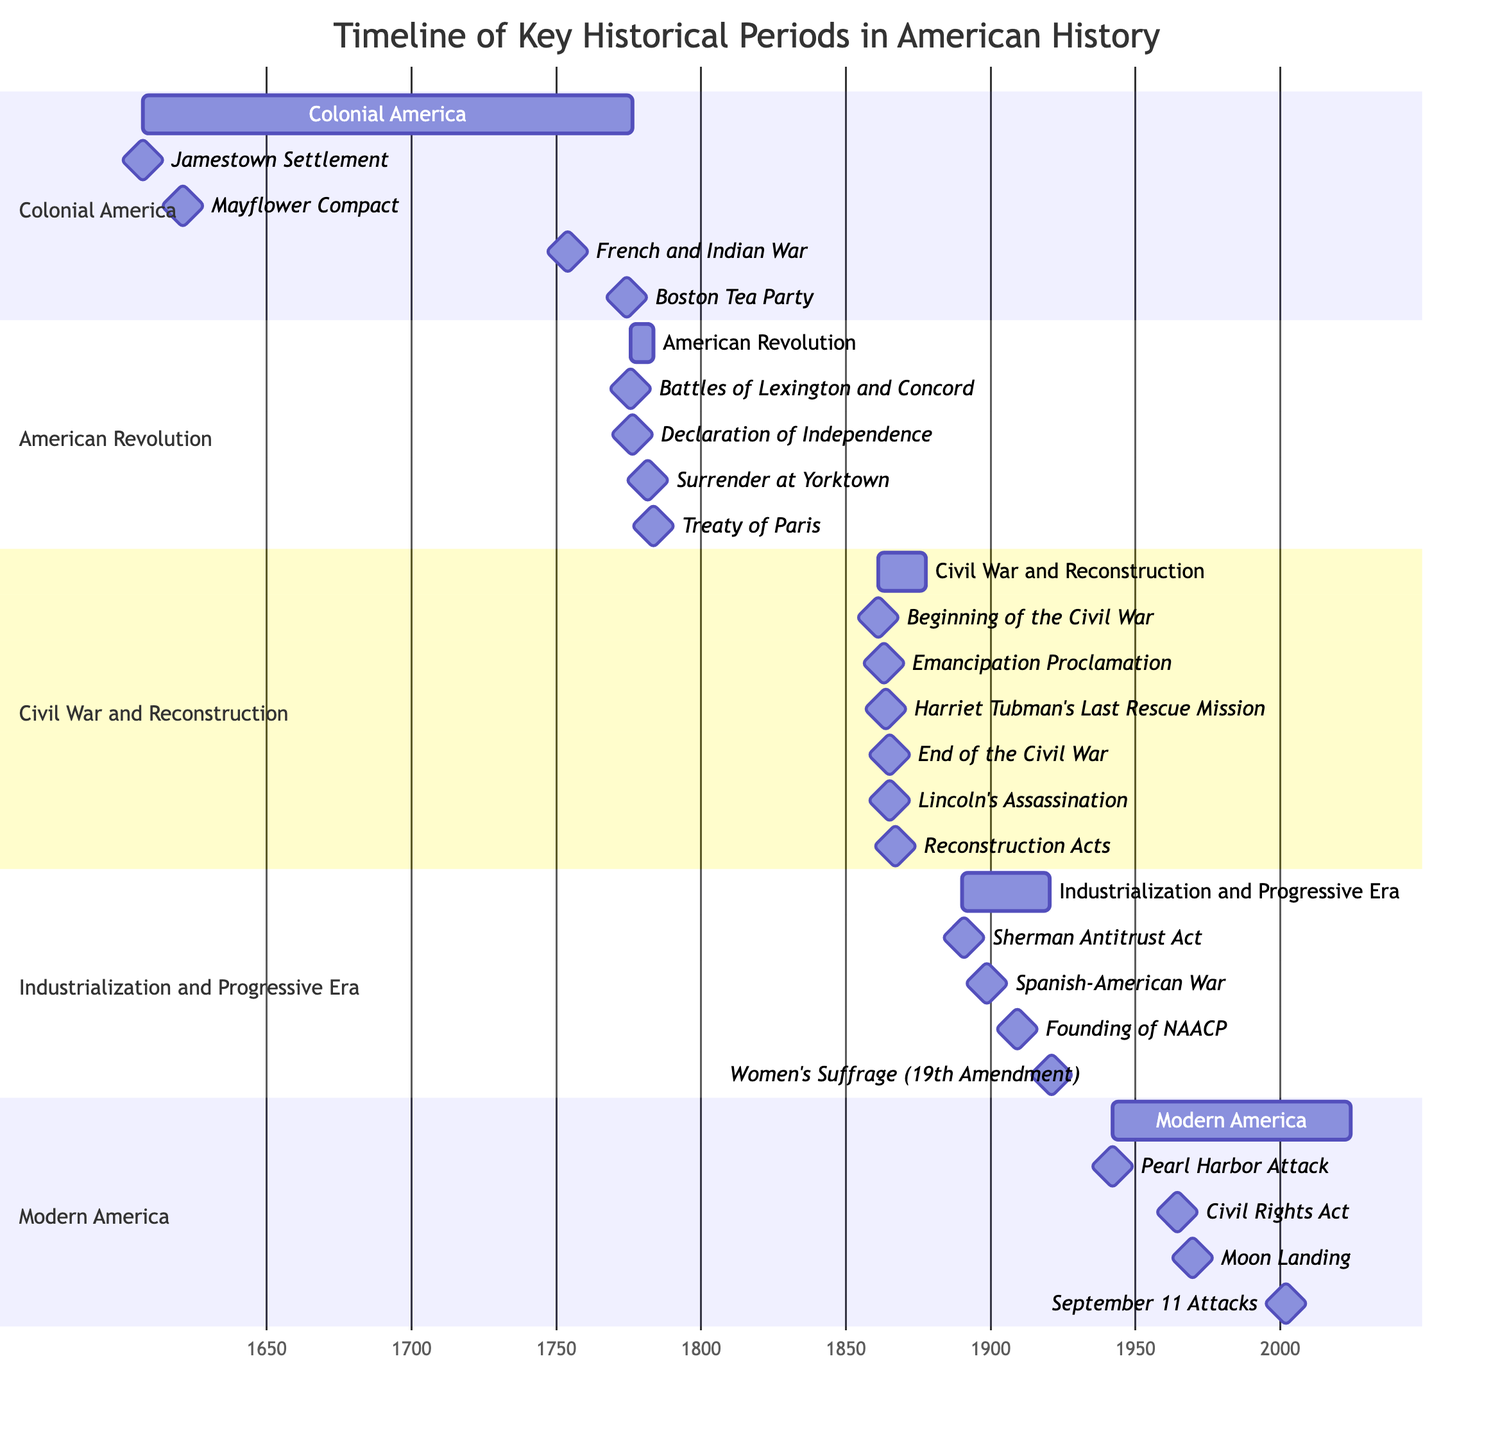What is the end date of the Colonial America period? The Colonial America period starts on May 14, 1607, and ends on July 4, 1776. By locating the "end date" for this section in the diagram, it is clear that July 4, 1776 is the specified date.
Answer: July 4, 1776 How many milestones are there in the Civil War and Reconstruction section? The Civil War and Reconstruction section contains the following milestones: Beginning of the Civil War, Emancipation Proclamation, Harriet Tubman's Last Rescue Mission, End of the Civil War, Lincoln's Assassination, and Reconstruction Acts. Counting each milestone shows there are six in total.
Answer: 6 Which milestone marks the beginning of the American Revolution? The American Revolution section lists several milestones. The first milestone is "Battles of Lexington and Concord," which occurs on April 19, 1775, and it indicates the starting point of the American Revolution.
Answer: Battles of Lexington and Concord In which historical period did Harriet Tubman's Last Rescue Mission occur? By examining the milestones under the "Civil War and Reconstruction" section, it states that Harriet Tubman's Last Rescue Mission took place on December 1, 1863. This identifies her mission as part of the Civil War and Reconstruction period.
Answer: Civil War and Reconstruction Which two major events in Modern America occurred in the 1960s? The Modern America section includes several milestones, two of which occur in the 1960s: the Civil Rights Act on July 2, 1964, and the Moon Landing on July 20, 1969. Therefore, these two events happened during that decade.
Answer: Civil Rights Act and Moon Landing What is the duration of the Industrialization and Progressive Era? The Industrialization and Progressive Era spans from January 1, 1890, to January 1, 1920. Calculating the time between these two dates gives a duration of 30 years.
Answer: 30 years Which event marks the end of the American Revolution? The last milestone in the American Revolution section is the Treaty of Paris, which happened on September 3, 1783. This milestone signifies the conclusion of the American Revolution.
Answer: Treaty of Paris What significant legislative act occurred in 1867 during the Civil War and Reconstruction period? Among the milestones in the Civil War and Reconstruction section, the Reconstruction Acts on March 2, 1867, represent a significant legislative achievement that occurred during this time.
Answer: Reconstruction Acts What is the earliest date represented in the timeline? The earliest date indicated in the timeline belongs to the Colonial America section with the milestone for the Jamestown Settlement, which is marked on May 14, 1607. This confirms May 14, 1607 as the timeline's starting point.
Answer: May 14, 1607 